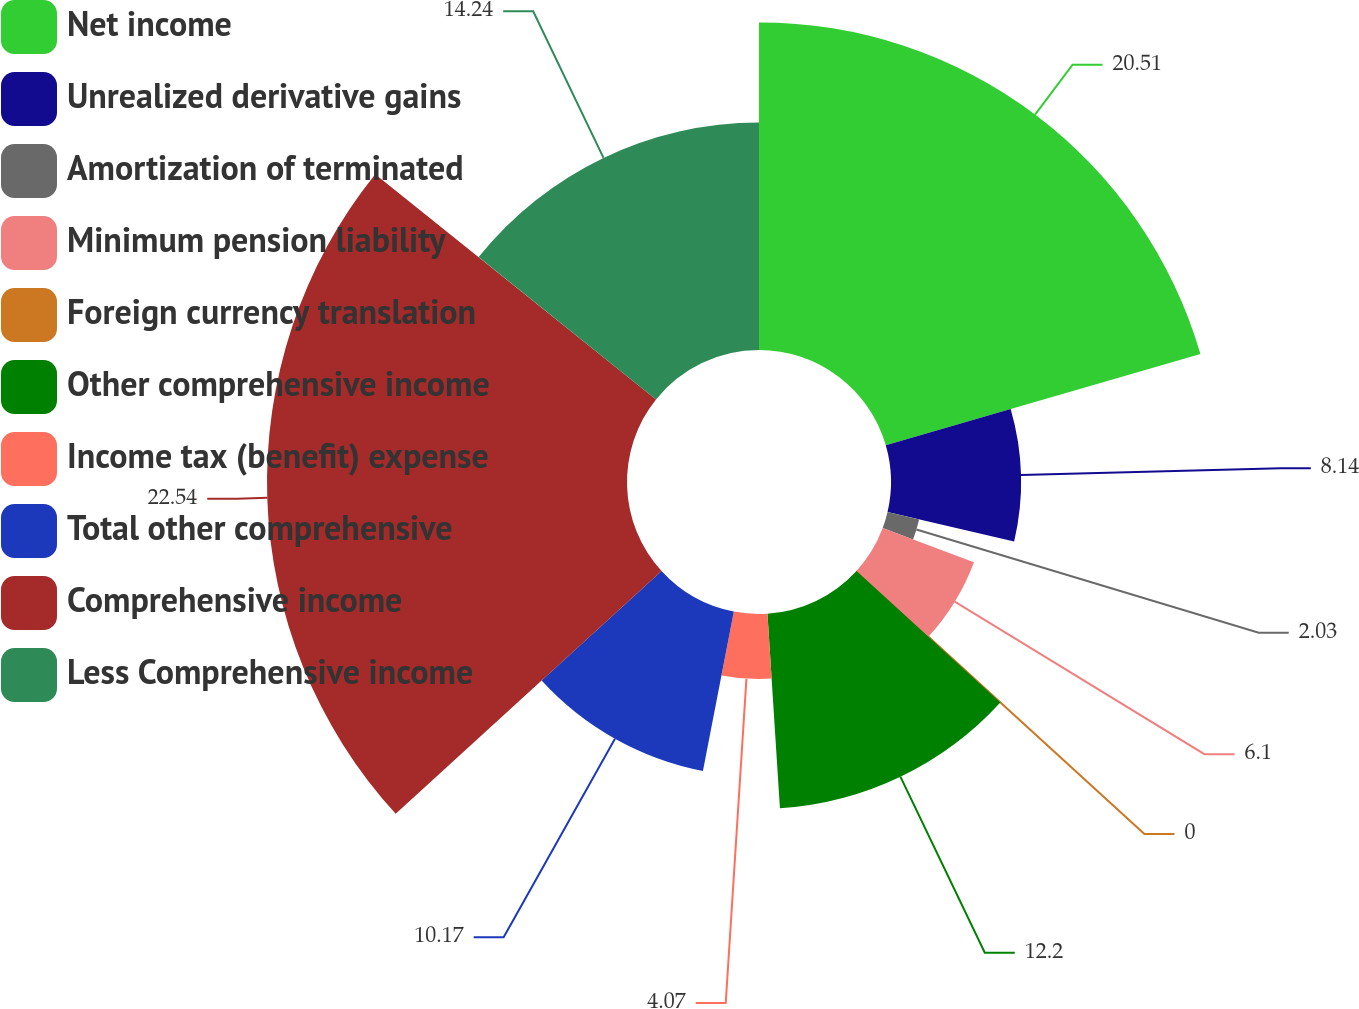<chart> <loc_0><loc_0><loc_500><loc_500><pie_chart><fcel>Net income<fcel>Unrealized derivative gains<fcel>Amortization of terminated<fcel>Minimum pension liability<fcel>Foreign currency translation<fcel>Other comprehensive income<fcel>Income tax (benefit) expense<fcel>Total other comprehensive<fcel>Comprehensive income<fcel>Less Comprehensive income<nl><fcel>20.51%<fcel>8.14%<fcel>2.03%<fcel>6.1%<fcel>0.0%<fcel>12.2%<fcel>4.07%<fcel>10.17%<fcel>22.54%<fcel>14.24%<nl></chart> 